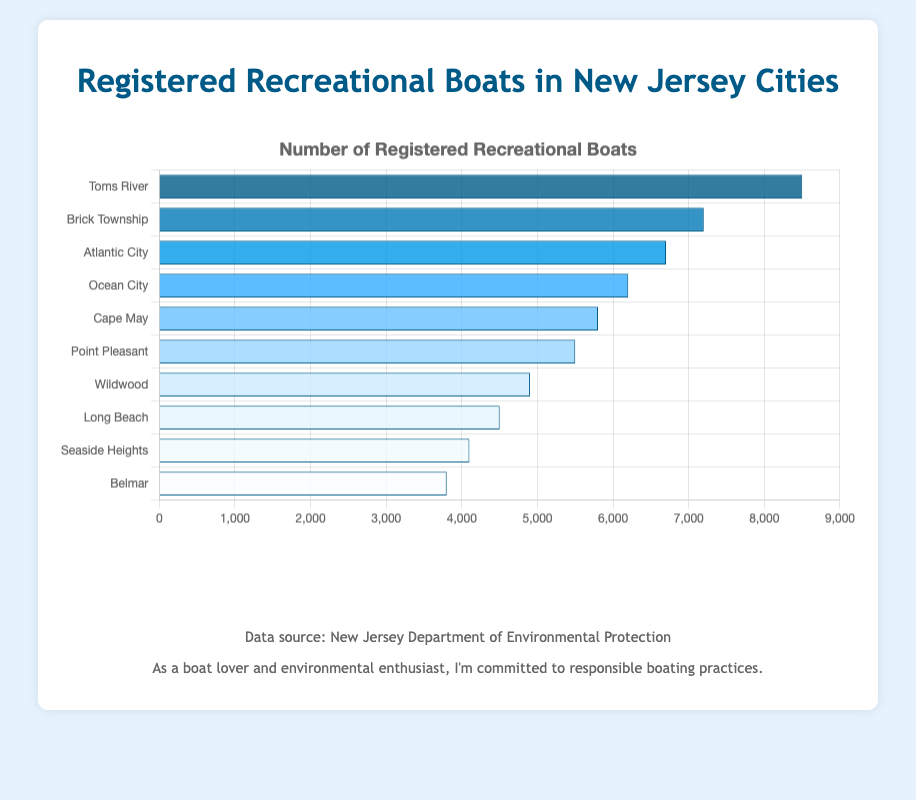Which city has the highest number of registered recreational boats? To find the city with the highest number, look for the bar that extends the farthest to the right.
Answer: Toms River How many more registered boats does Toms River have compared to Brick Township? The number of registered boats in Toms River is 8500, and in Brick Township, it's 7200. Subtract Brick Township's count from Toms River's count (8500 - 7200).
Answer: 1300 What is the total number of registered recreational boats in Atlantic City and Ocean City combined? Add the number of registered boats in Atlantic City (6700) and Ocean City (6200) together (6700 + 6200).
Answer: 12900 Is the number of registered boats in Cape May greater than in Point Pleasant? Compare the number of registered boats in Cape May (5800) to Point Pleasant (5500).
Answer: Yes What is the difference between the number of registered boats in Wildwood and the number in Long Beach? Subtract Long Beach's number from Wildwood’s (4900 - 4500).
Answer: 400 How many cities have more than 6000 registered recreational boats? Identify the cities with more than 6000 boats: Toms River, Brick Township, Atlantic City, Ocean City. Count these cities.
Answer: 4 Which city has the fewest registered recreational boats? Look for the bar that extends the least to the right.
Answer: Belmar What's the average number of registered recreational boats in the listed cities? Sum the registered boats in all cities (8500 + 7200 + 6700 + 6200 + 5800 + 5500 + 4900 + 4500 + 4100 + 3800 = 56700) and divide by the number of cities (10).
Answer: 5670 Rank the cities in order of their number of registered recreational boats from highest to lowest. List the cities by the length of their horizontal bars from longest to shortest: Toms River, Brick Township, Atlantic City, Ocean City, Cape May, Point Pleasant, Wildwood, Long Beach, Seaside Heights, Belmar.
Answer: Toms River, Brick Township, Atlantic City, Ocean City, Cape May, Point Pleasant, Wildwood, Long Beach, Seaside Heights, Belmar What is the combined number of registered boats for the three cities with the fewest boats? Add the registered boats in Wildwood (4900), Long Beach (4500), and Belmar (3800) together (4900 + 4500 + 3800).
Answer: 13200 